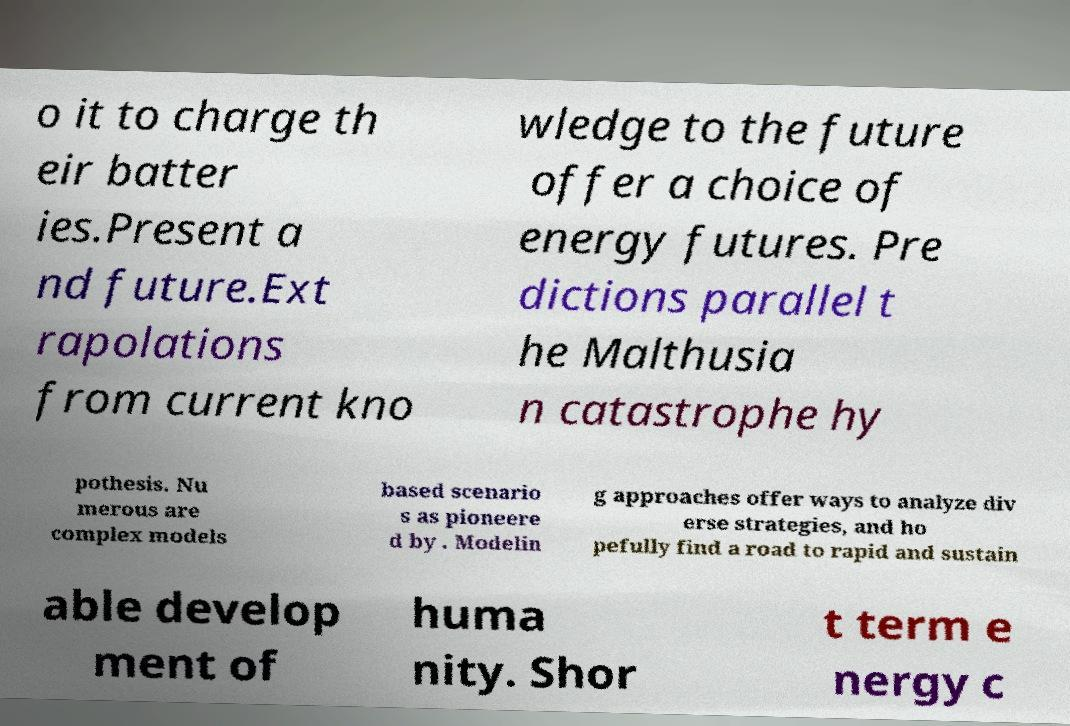Please read and relay the text visible in this image. What does it say? o it to charge th eir batter ies.Present a nd future.Ext rapolations from current kno wledge to the future offer a choice of energy futures. Pre dictions parallel t he Malthusia n catastrophe hy pothesis. Nu merous are complex models based scenario s as pioneere d by . Modelin g approaches offer ways to analyze div erse strategies, and ho pefully find a road to rapid and sustain able develop ment of huma nity. Shor t term e nergy c 